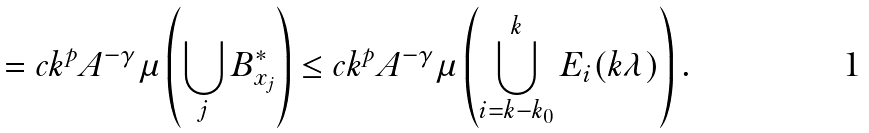Convert formula to latex. <formula><loc_0><loc_0><loc_500><loc_500>= c k ^ { p } A ^ { - \gamma } \mu \left ( \bigcup _ { j } B ^ { * } _ { x _ { j } } \right ) \leq c k ^ { p } A ^ { - \gamma } \mu \left ( \bigcup _ { i = k - k _ { 0 } } ^ { k } E _ { i } ( k \lambda ) \right ) .</formula> 